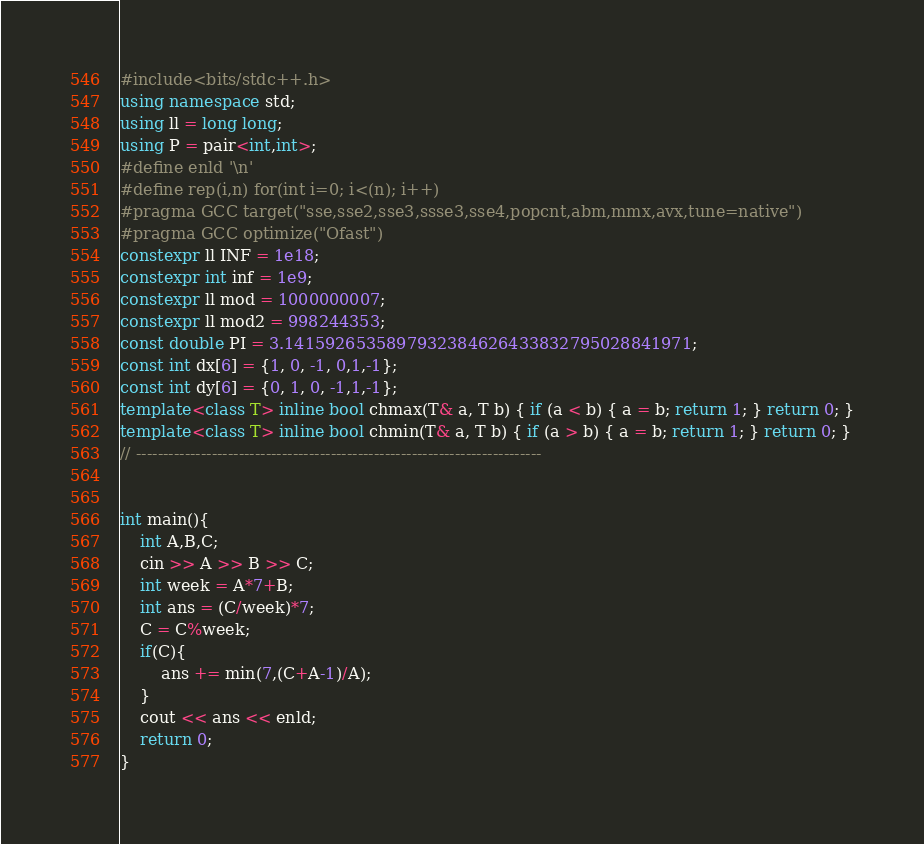Convert code to text. <code><loc_0><loc_0><loc_500><loc_500><_C++_>#include<bits/stdc++.h>
using namespace std;
using ll = long long;
using P = pair<int,int>;
#define enld '\n'
#define rep(i,n) for(int i=0; i<(n); i++)
#pragma GCC target("sse,sse2,sse3,ssse3,sse4,popcnt,abm,mmx,avx,tune=native")
#pragma GCC optimize("Ofast")
constexpr ll INF = 1e18;
constexpr int inf = 1e9;
constexpr ll mod = 1000000007;
constexpr ll mod2 = 998244353;
const double PI = 3.1415926535897932384626433832795028841971;
const int dx[6] = {1, 0, -1, 0,1,-1};
const int dy[6] = {0, 1, 0, -1,1,-1};
template<class T> inline bool chmax(T& a, T b) { if (a < b) { a = b; return 1; } return 0; }
template<class T> inline bool chmin(T& a, T b) { if (a > b) { a = b; return 1; } return 0; }
// ---------------------------------------------------------------------------


int main(){
    int A,B,C;
    cin >> A >> B >> C;
    int week = A*7+B;
    int ans = (C/week)*7;
    C = C%week;
    if(C){
        ans += min(7,(C+A-1)/A);
    }
    cout << ans << enld;
    return 0;
}
</code> 